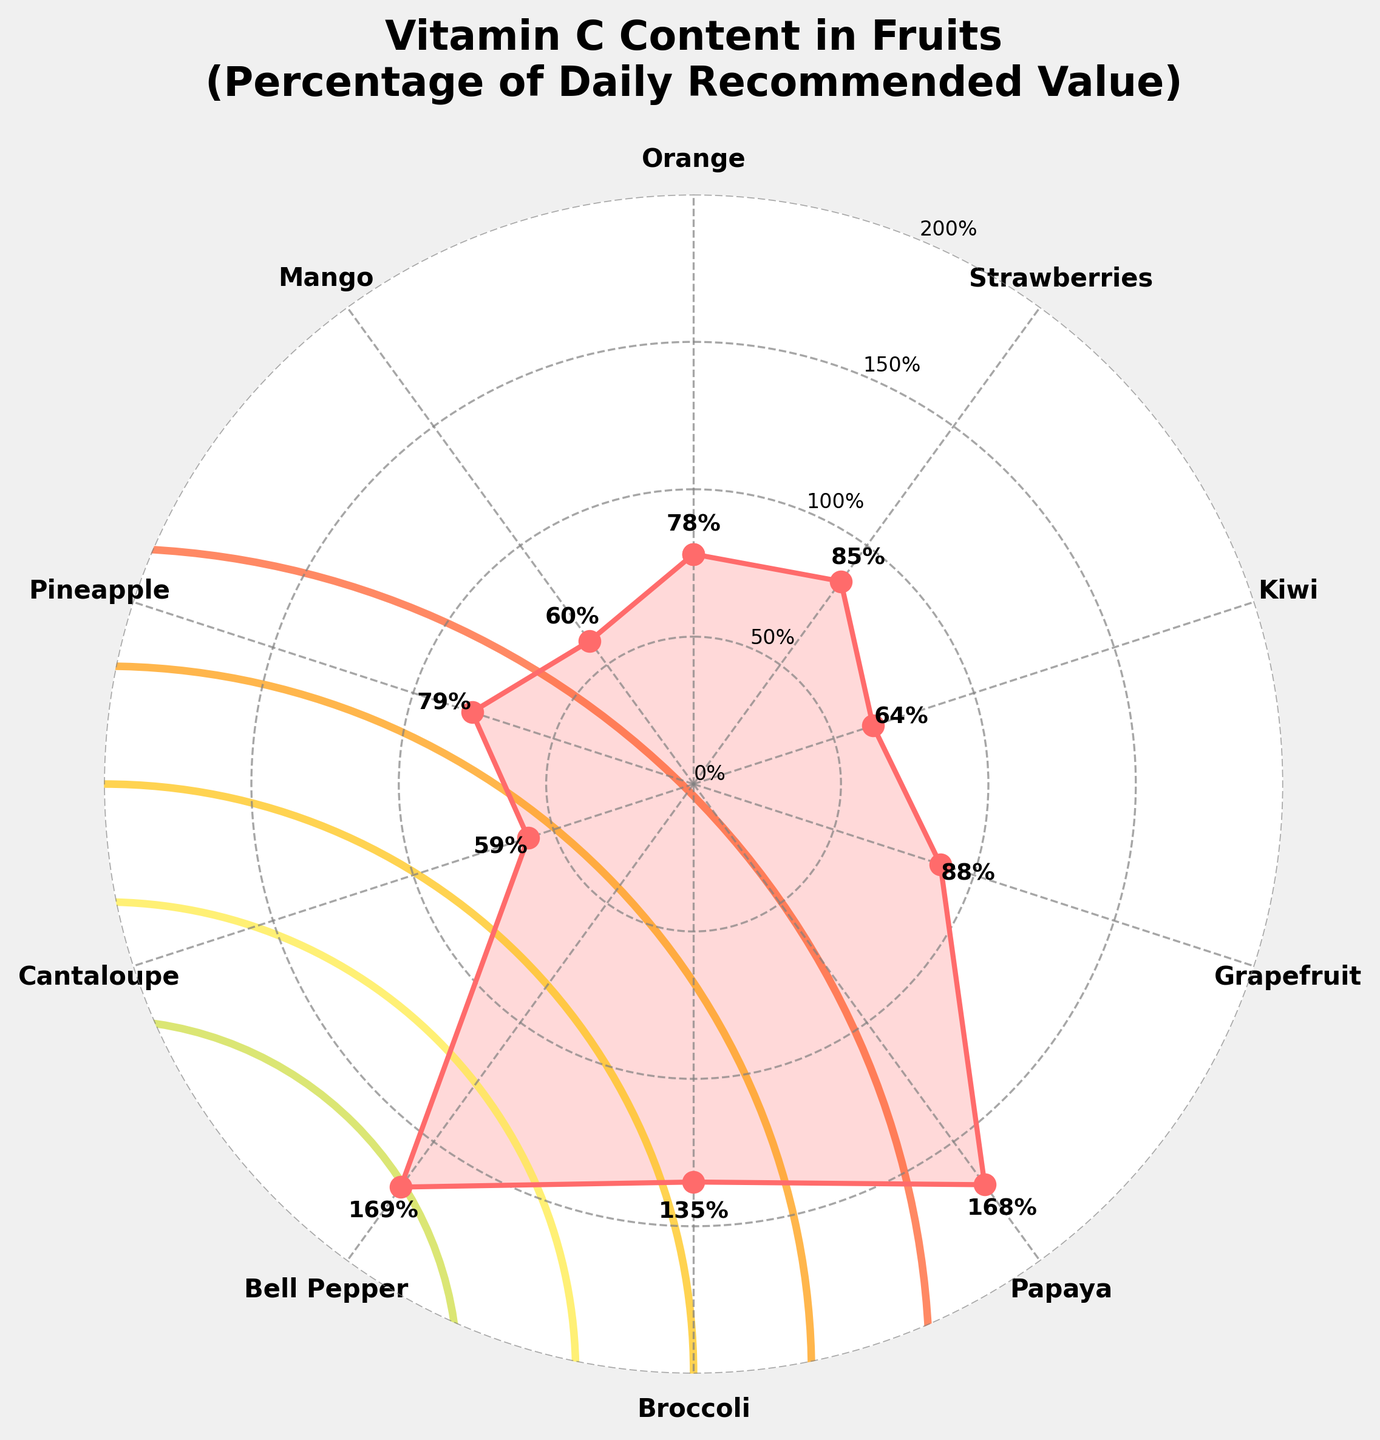What is the title of the figure? The title is usually placed at the top of the figure, clearly indicating the subject of the plot. In this case, the title is "Vitamin C Content in Fruits (Percentage of Daily Recommended Value)" which directly refers to what is being visualized.
Answer: "Vitamin C Content in Fruits (Percentage of Daily Recommended Value)" How many fruit types are shown in the figure? By counting the distinct labels around the circular plot, we can determine the number of fruit types shown.
Answer: 10 Which fruit has the highest Vitamin C percentage? To find the highest value, look for the fruit label at the maximum radial distance from the center of the plot. The label closest to the outer edge will be the highest. Bell Pepper shows the highest point at 169%.
Answer: Bell Pepper What is the Vitamin C percentage of Mango? Locate the label 'Mango' and refer to the percentage indicated by the corresponding data point. The radial distance marked for Mango is the value.
Answer: 60% Which three fruits have the lowest Vitamin C percentages? By examining the radial distances (percentages) from the center towards the edge, the three shortest distances represent the lowest percentages. They correspond to Cantaloupe (59%), Kiwi (64%), and Mango (60%).
Answer: Cantaloupe, Kiwi, Mango How does the Vitamin C percentage of Broccoli compare to that of Orange? Locate both data points by their fruit labels (Broccoli and Orange) and compare the radial distances (percentages). Broccoli's radial distance is farther, indicating a higher percentage. Broccoli has 135% while Orange has 78%.
Answer: Broccoli has a higher percentage than Orange What's the average Vitamin C percentage of all the fruits shown? Sum all the Vitamin C percentages: 78 + 85 + 64 + 88 + 168 + 135 + 169 + 59 + 79 + 60. The total is 985. Divide by the number of fruits, which is 10. The average is 98.5%.
Answer: 98.5% Is there any fruit that meets more than 100% of the daily recommended Vitamin C intake? Check if any of the fruit labels are associated with data points beyond 100% on the radial axis. Papaya, Broccoli, and Bell Pepper each exceed 100%, meeting more than the daily recommended value.
Answer: Yes, there are three: Papaya, Broccoli, and Bell Pepper Which fruit has a Vitamin C percentage closest to 80%? Identify the point on the radial axis that is nearest but not exceeding 80%. Pineapple has the closest percentage to 80% with a value of 79%.
Answer: Pineapple What is the median Vitamin C percentage of the fruits shown? List all the percentages in ascending order and find the middle value. The sorted values are: 59, 60, 64, 78, 79, 85, 88, 135, 168, 169. Since there are 10 data points, the median is the average of the 5th and 6th values. (79 + 85) / 2 = 82%.
Answer: 82% 